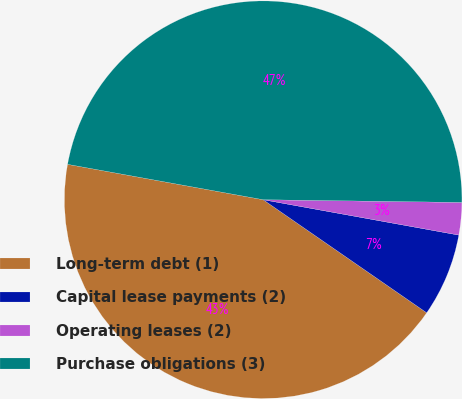<chart> <loc_0><loc_0><loc_500><loc_500><pie_chart><fcel>Long-term debt (1)<fcel>Capital lease payments (2)<fcel>Operating leases (2)<fcel>Purchase obligations (3)<nl><fcel>43.22%<fcel>6.78%<fcel>2.63%<fcel>47.37%<nl></chart> 